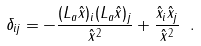<formula> <loc_0><loc_0><loc_500><loc_500>\delta _ { i j } = - \frac { ( L _ { a } \hat { x } ) _ { i } ( L _ { a } \hat { x } ) _ { j } } { \hat { x } ^ { 2 } } + \frac { \hat { x } _ { i } \hat { x } _ { j } } { \hat { x } ^ { 2 } } \ .</formula> 